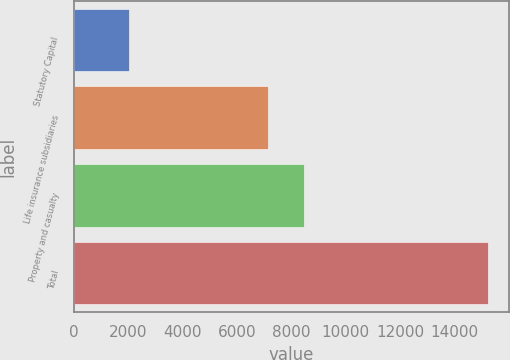Convert chart. <chart><loc_0><loc_0><loc_500><loc_500><bar_chart><fcel>Statutory Capital<fcel>Life insurance subsidiaries<fcel>Property and casualty<fcel>Total<nl><fcel>2014<fcel>7157<fcel>8478.2<fcel>15226<nl></chart> 